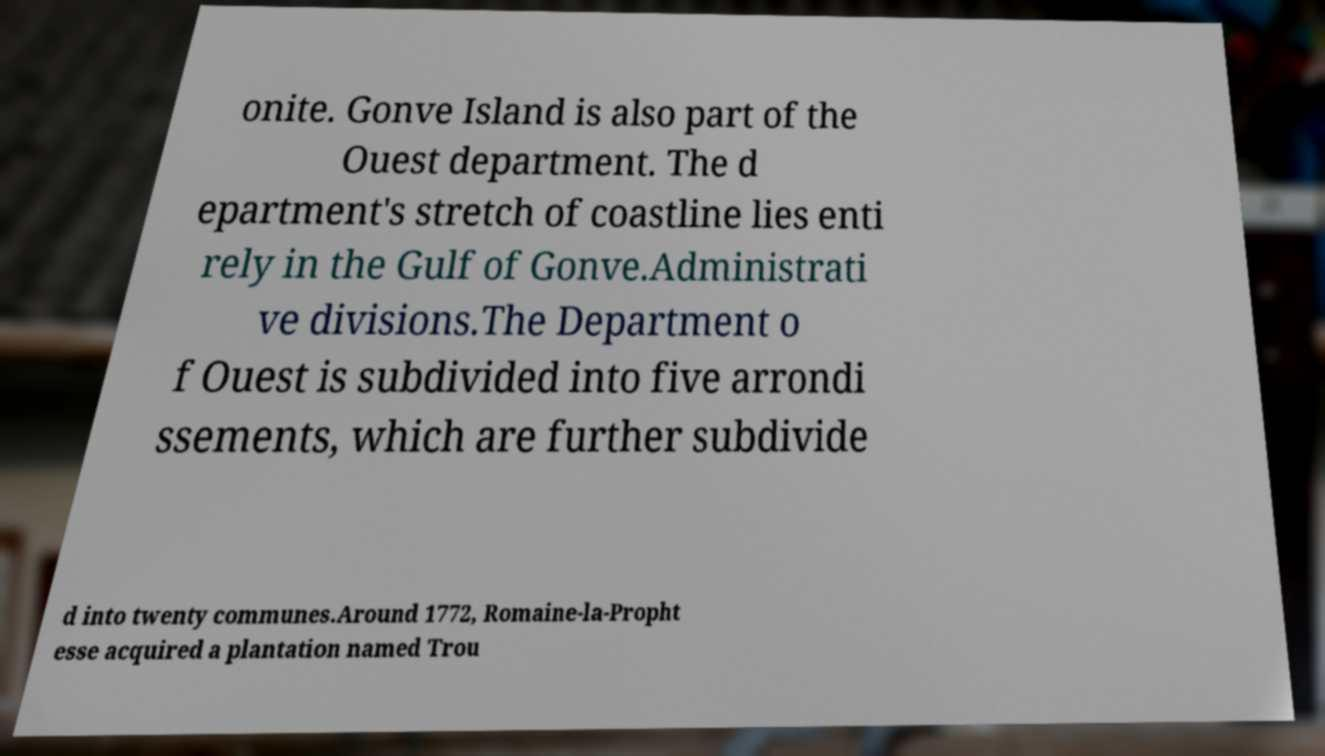Please read and relay the text visible in this image. What does it say? onite. Gonve Island is also part of the Ouest department. The d epartment's stretch of coastline lies enti rely in the Gulf of Gonve.Administrati ve divisions.The Department o f Ouest is subdivided into five arrondi ssements, which are further subdivide d into twenty communes.Around 1772, Romaine-la-Propht esse acquired a plantation named Trou 